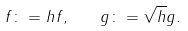<formula> <loc_0><loc_0><loc_500><loc_500>f \colon = h f , \quad g \colon = \sqrt { h } g .</formula> 